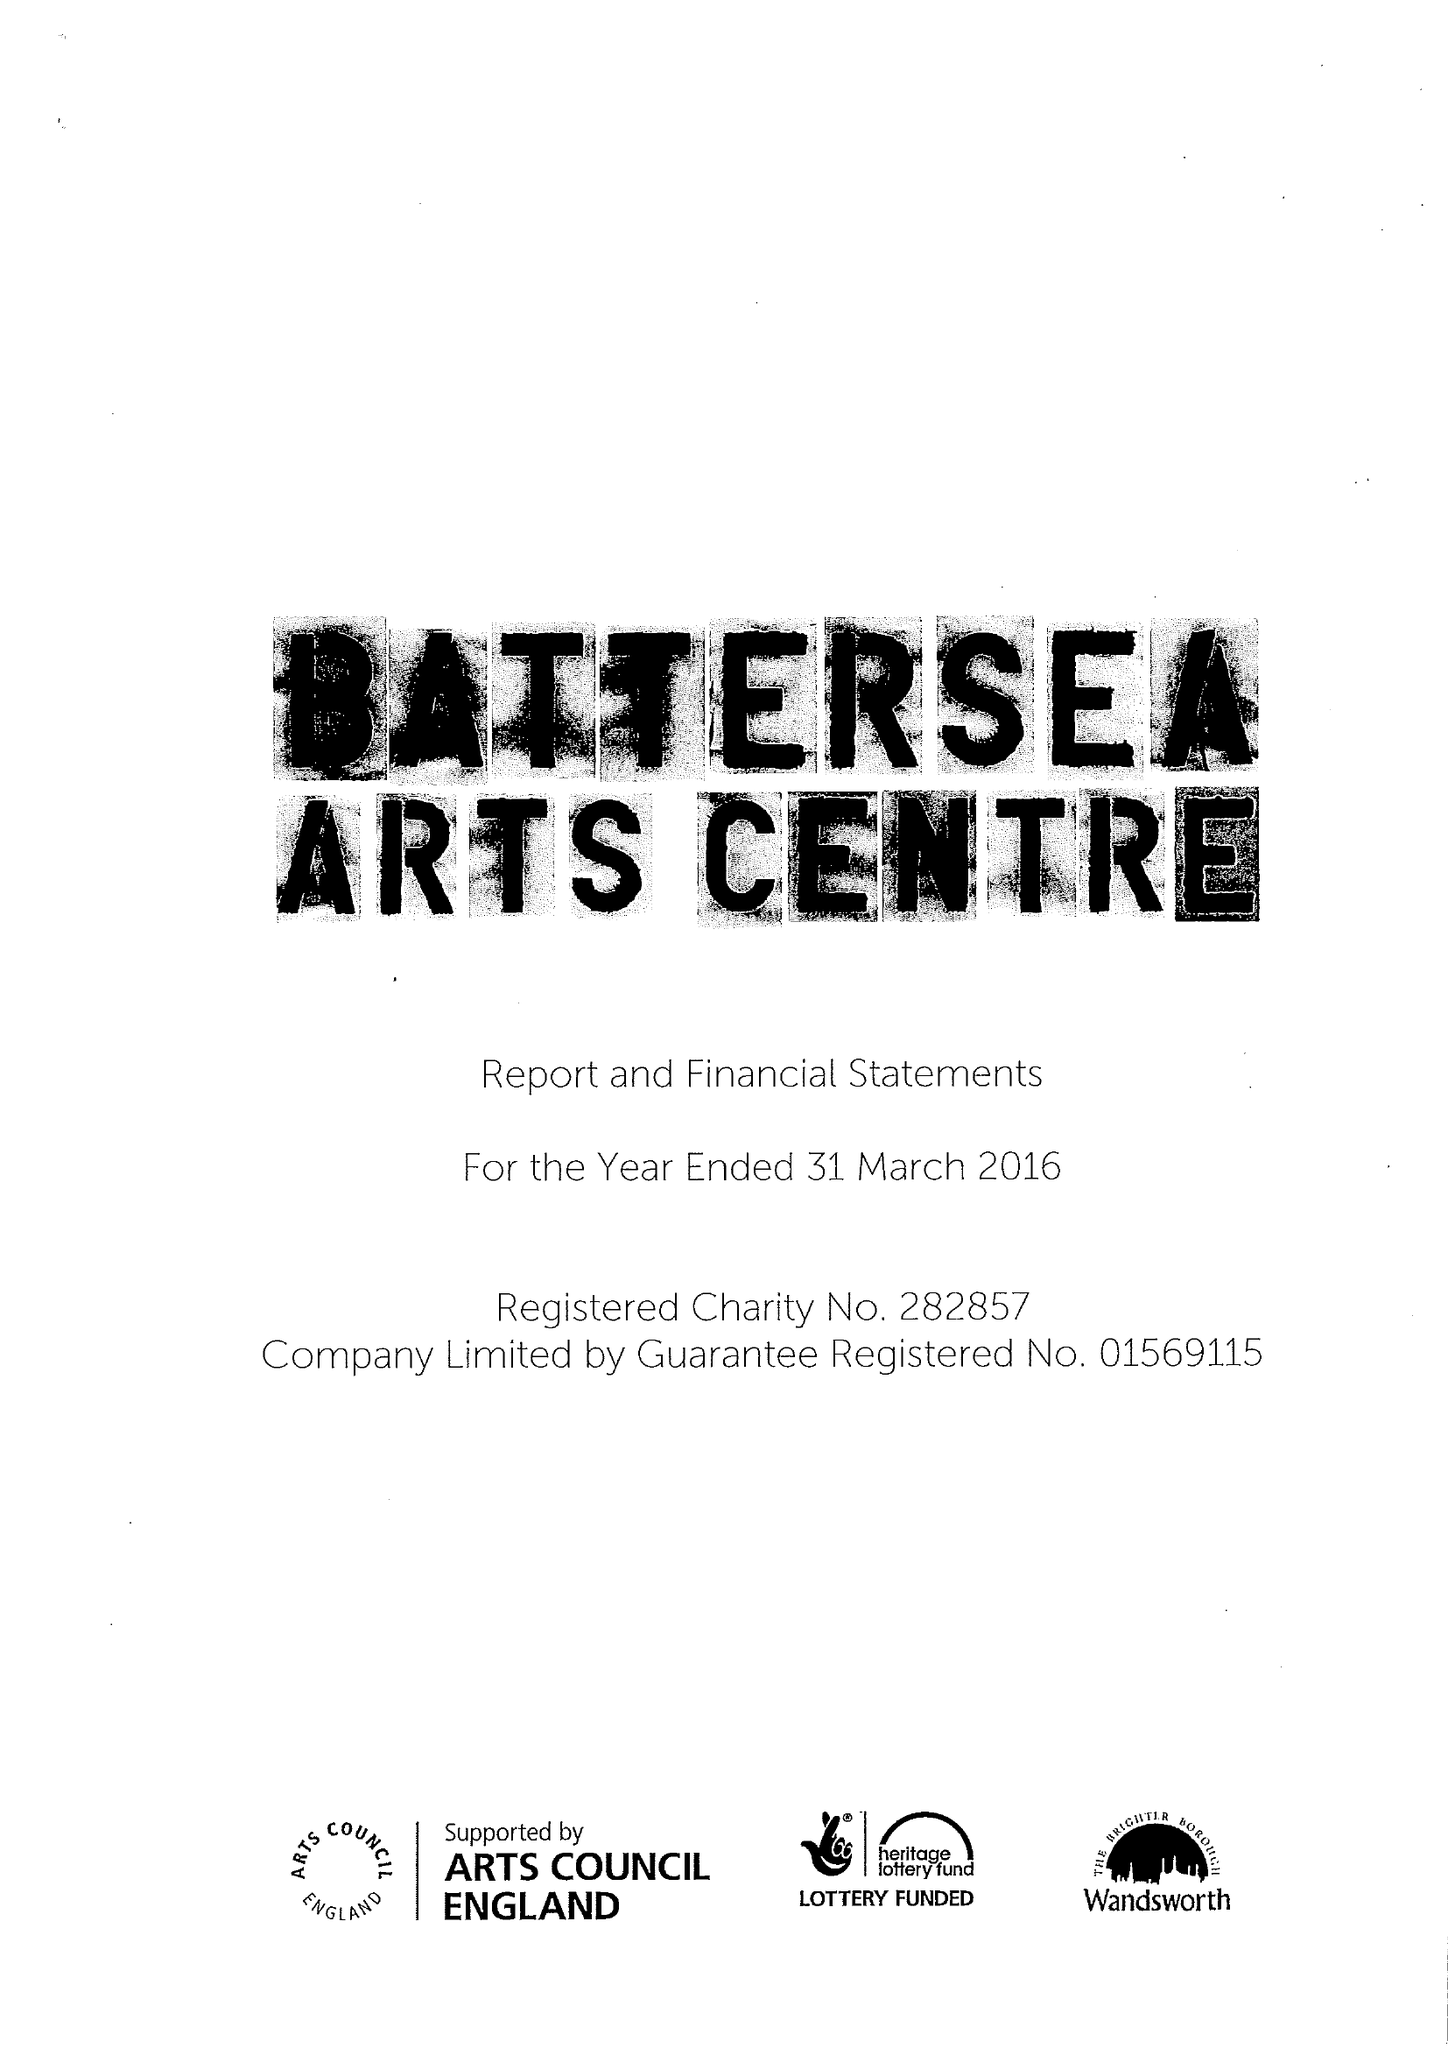What is the value for the charity_name?
Answer the question using a single word or phrase. Battersea Arts Centre 